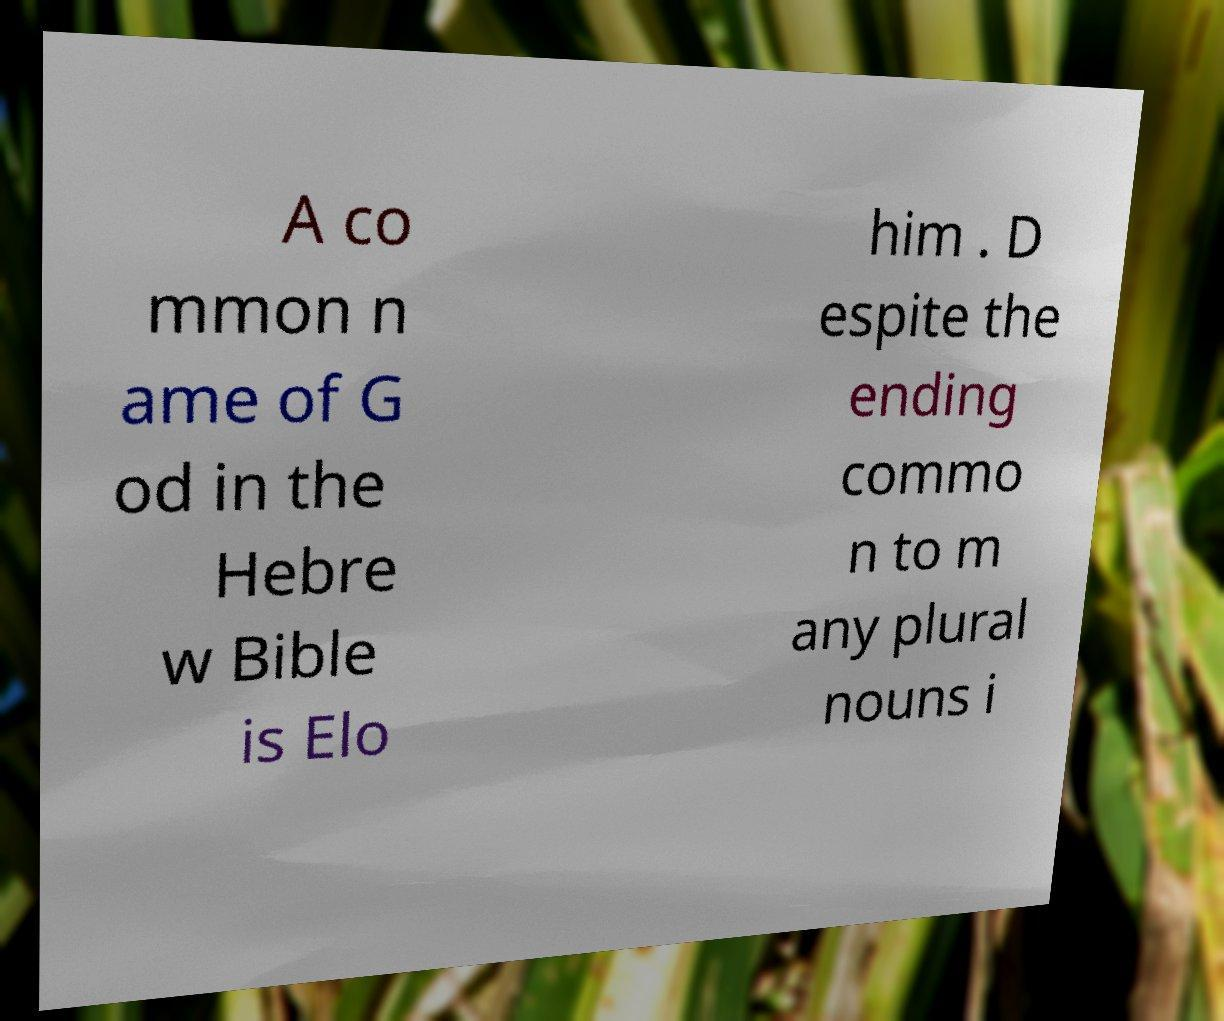For documentation purposes, I need the text within this image transcribed. Could you provide that? A co mmon n ame of G od in the Hebre w Bible is Elo him . D espite the ending commo n to m any plural nouns i 